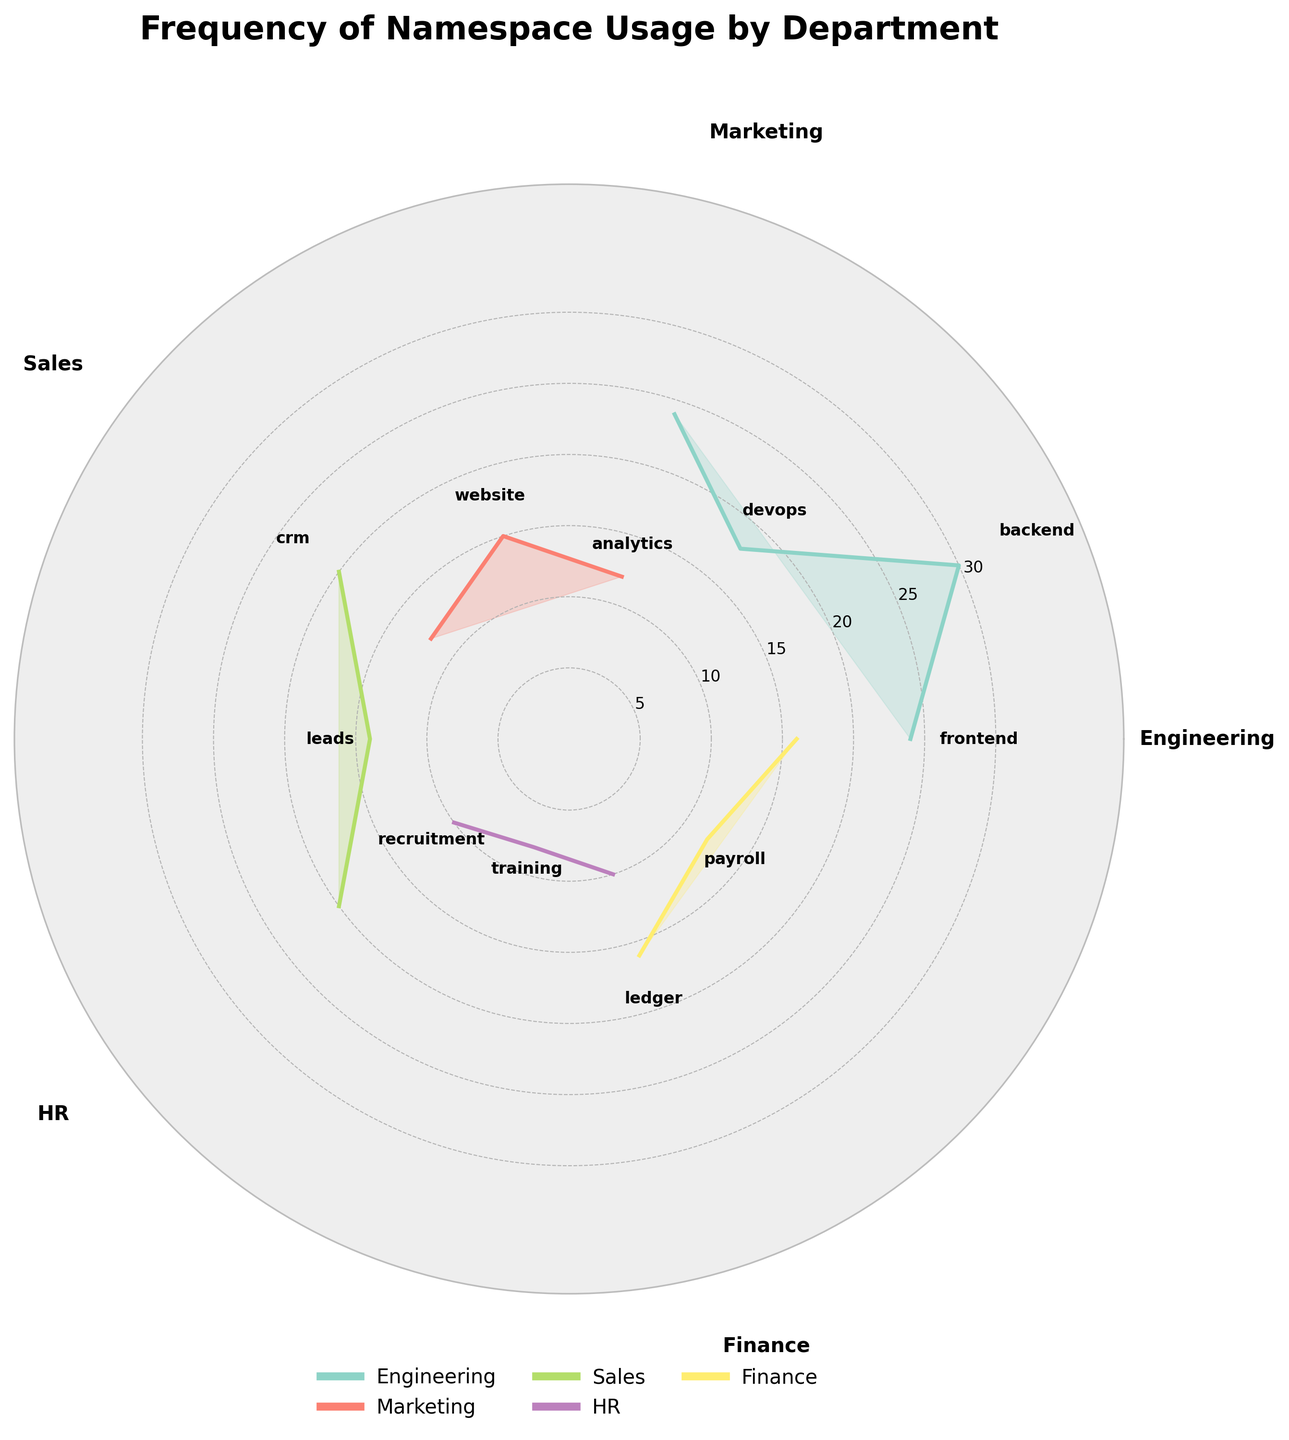What's the title of the figure? The title can be found at the top of the plot, which summarizes what the chart is about.
Answer: Frequency of Namespace Usage by Department Which department has the highest namespace usage frequency? From the polar plot, observe the radial distance for each department, and identify which department has the highest values. This corresponds to the longest radii. In this case, the Engineering department has the highest namespace usage frequency.
Answer: Engineering How many namespaces are associated with the Marketing department? Count the number of data points (or namespaces) plotted in the sector corresponding to the Marketing department.
Answer: 2 What is the total namespace usage frequency for the Sales department? Sum the usage frequencies of all namespaces in the Sales department sector. This includes adding the frequencies for both 'crm' and 'leads'.
Answer: 34 How does the usage frequency of the 'ledger' namespace in the Finance department compare to the 'analytics' namespace in the Marketing department? Find the radial lengths for both 'ledger' and 'analytics' namespaces. Compare these two values to determine which is higher.
Answer: Ledger (Finance) Which namespace is most frequently used in the Engineering department? Identify the namespace within the Engineering segment which has the highest radial length.
Answer: Backend What is the average usage frequency of namespaces in the HR department? Add the usage frequencies of both 'recruitment' and 'training', then divide by the number of namespaces in HR to get the average. (10 + 8) / 2 = 9.
Answer: 9 Which namespace is used more frequently: 'website' in Marketing or 'payroll' in Finance? Compare the radial lengths of the 'website' namespace in Marketing and the 'payroll' namespace in Finance to determine which one is used more frequently.
Answer: Website (Marketing) What is the combined usage frequency for namespaces in the Finance and HR departments? Sum the usage frequencies of all namespaces in both the Finance and HR departments. (16 + 12) + (10 + 8) = 46.
Answer: 46 How many unique departments are represented in the figure? Count the number of unique department labels indicated around the perimeter of the polar plot.
Answer: 5 